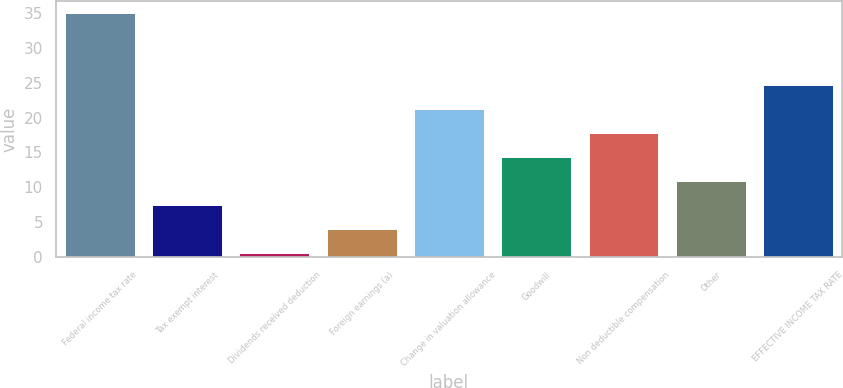Convert chart. <chart><loc_0><loc_0><loc_500><loc_500><bar_chart><fcel>Federal income tax rate<fcel>Tax exempt interest<fcel>Dividends received deduction<fcel>Foreign earnings (a)<fcel>Change in valuation allowance<fcel>Goodwill<fcel>Non deductible compensation<fcel>Other<fcel>EFFECTIVE INCOME TAX RATE<nl><fcel>35<fcel>7.48<fcel>0.6<fcel>4.04<fcel>21.24<fcel>14.36<fcel>17.8<fcel>10.92<fcel>24.68<nl></chart> 